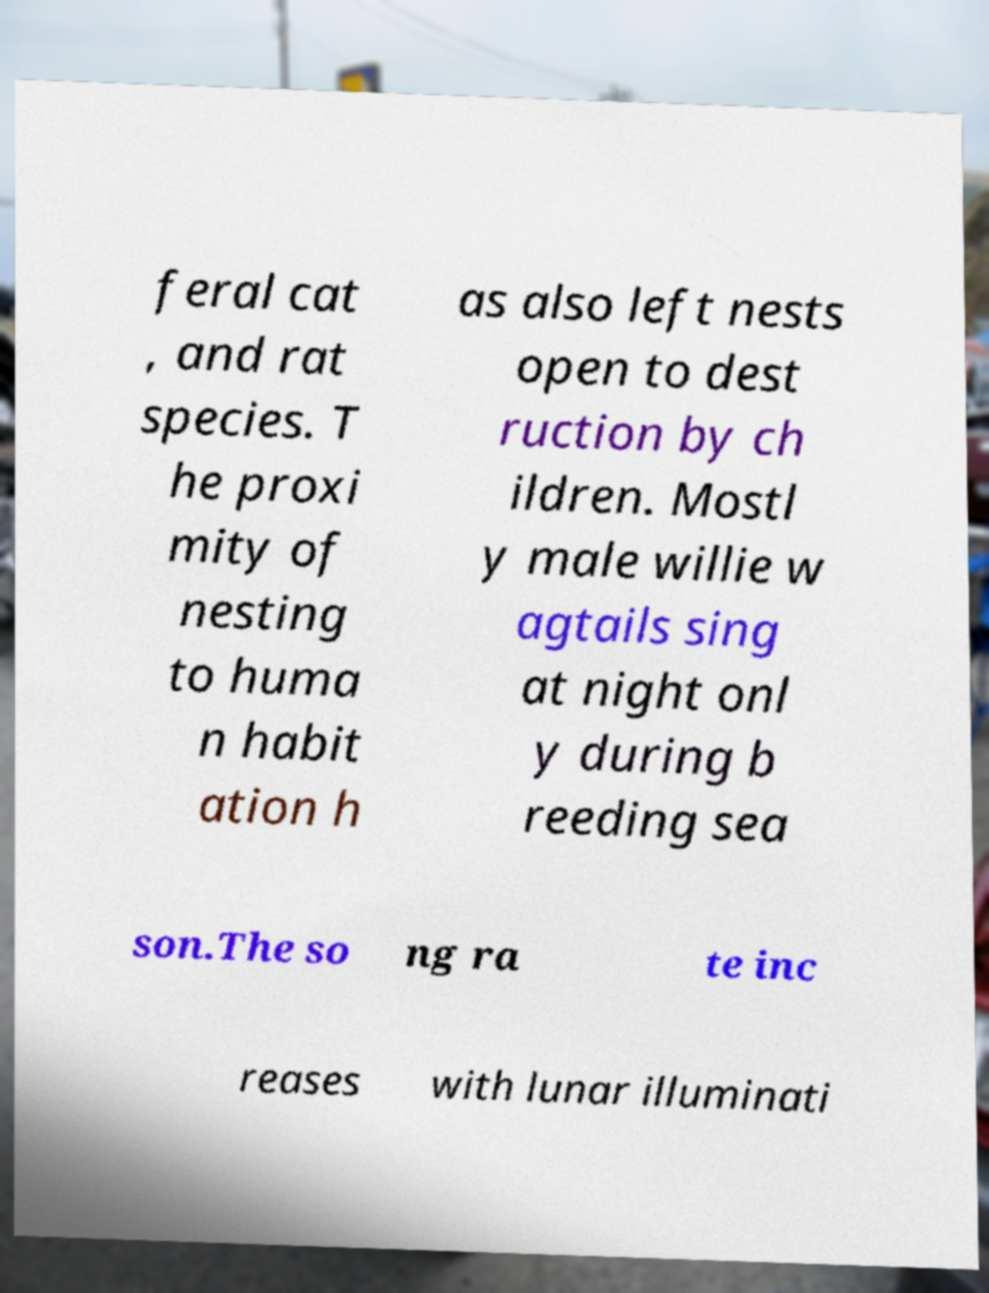Please identify and transcribe the text found in this image. feral cat , and rat species. T he proxi mity of nesting to huma n habit ation h as also left nests open to dest ruction by ch ildren. Mostl y male willie w agtails sing at night onl y during b reeding sea son.The so ng ra te inc reases with lunar illuminati 